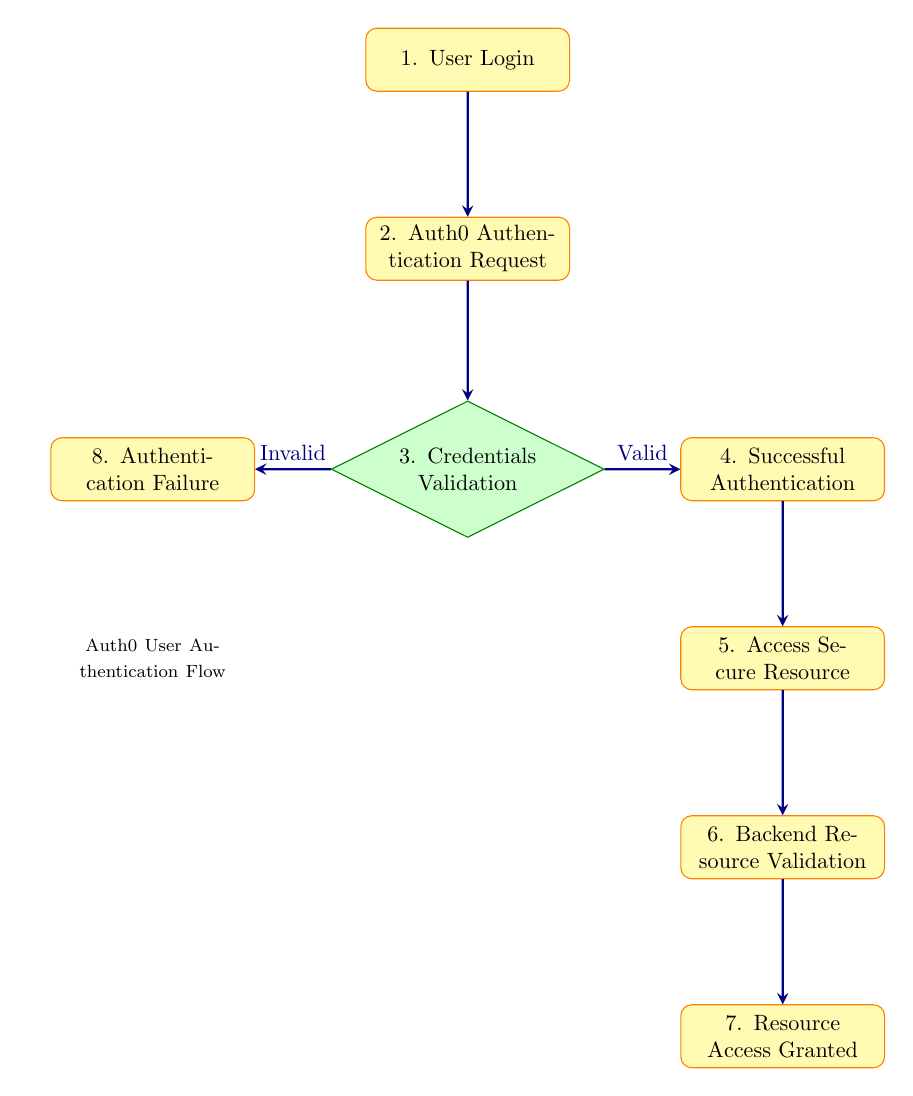What is the total number of nodes in the diagram? The diagram includes eight distinct nodes that represent different steps in the user authentication process with Auth0. Each step contributes to the overall flow of the authentication process.
Answer: 8 What follows after "Successful Authentication"? After "Successful Authentication," the next step in the process is "Access Secure Resource," which indicates that the user can now access resources using the obtained access token.
Answer: Access Secure Resource What action does the user take to initiate the authentication process? The user initiates the authentication process by providing their login credentials, which is represented by the first node labeled "User Login."
Answer: User Login What happens if the credentials are deemed invalid? If the credentials are invalid, the flow indicates that "Authentication Failure" occurs, and an error message is returned by Auth0. This is represented by a decision point leading to a failure node.
Answer: Authentication Failure What is required for the backend to grant access to the secure resource? The backend requires a successful validation of the access token with Auth0 to grant access to the secure resource. This is detailed in the edge connecting "Backend Resource Validation" to "Resource Access Granted."
Answer: Token validation successful What is the second step in the authentication process? The second step after the user submits their login request is the "Auth0 Authentication Request," where the user’s credentials are sent to Auth0 for further processing.
Answer: Auth0 Authentication Request What occurs during the third node, "Credentials Validation"? During "Credentials Validation," the system checks the provided user credentials against the identity providers configured in Auth0 to determine their validity, leading to either successful or failed authentication paths.
Answer: Credentials Validation How many different outcomes are possible after "Credentials Validation"? There are two possible outcomes after "Credentials Validation": one leads to "Successful Authentication" if valid and the other leads to "Authentication Failure" if invalid.
Answer: 2 